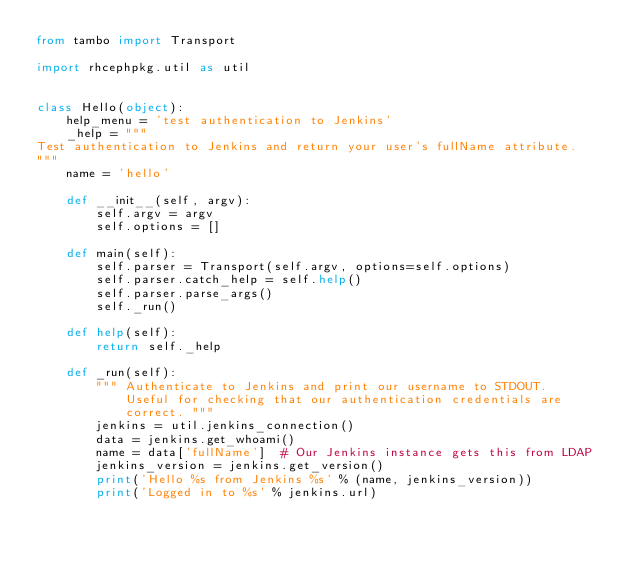<code> <loc_0><loc_0><loc_500><loc_500><_Python_>from tambo import Transport

import rhcephpkg.util as util


class Hello(object):
    help_menu = 'test authentication to Jenkins'
    _help = """
Test authentication to Jenkins and return your user's fullName attribute.
"""
    name = 'hello'

    def __init__(self, argv):
        self.argv = argv
        self.options = []

    def main(self):
        self.parser = Transport(self.argv, options=self.options)
        self.parser.catch_help = self.help()
        self.parser.parse_args()
        self._run()

    def help(self):
        return self._help

    def _run(self):
        """ Authenticate to Jenkins and print our username to STDOUT.
            Useful for checking that our authentication credentials are
            correct. """
        jenkins = util.jenkins_connection()
        data = jenkins.get_whoami()
        name = data['fullName']  # Our Jenkins instance gets this from LDAP
        jenkins_version = jenkins.get_version()
        print('Hello %s from Jenkins %s' % (name, jenkins_version))
        print('Logged in to %s' % jenkins.url)
</code> 